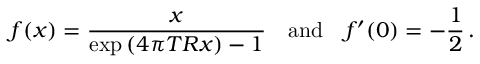<formula> <loc_0><loc_0><loc_500><loc_500>f ( x ) = \frac { x } { \exp { ( 4 \pi T R x ) } - 1 } \quad a n d \quad f ^ { \prime } ( 0 ) = - \frac { 1 } { 2 } \, { . }</formula> 